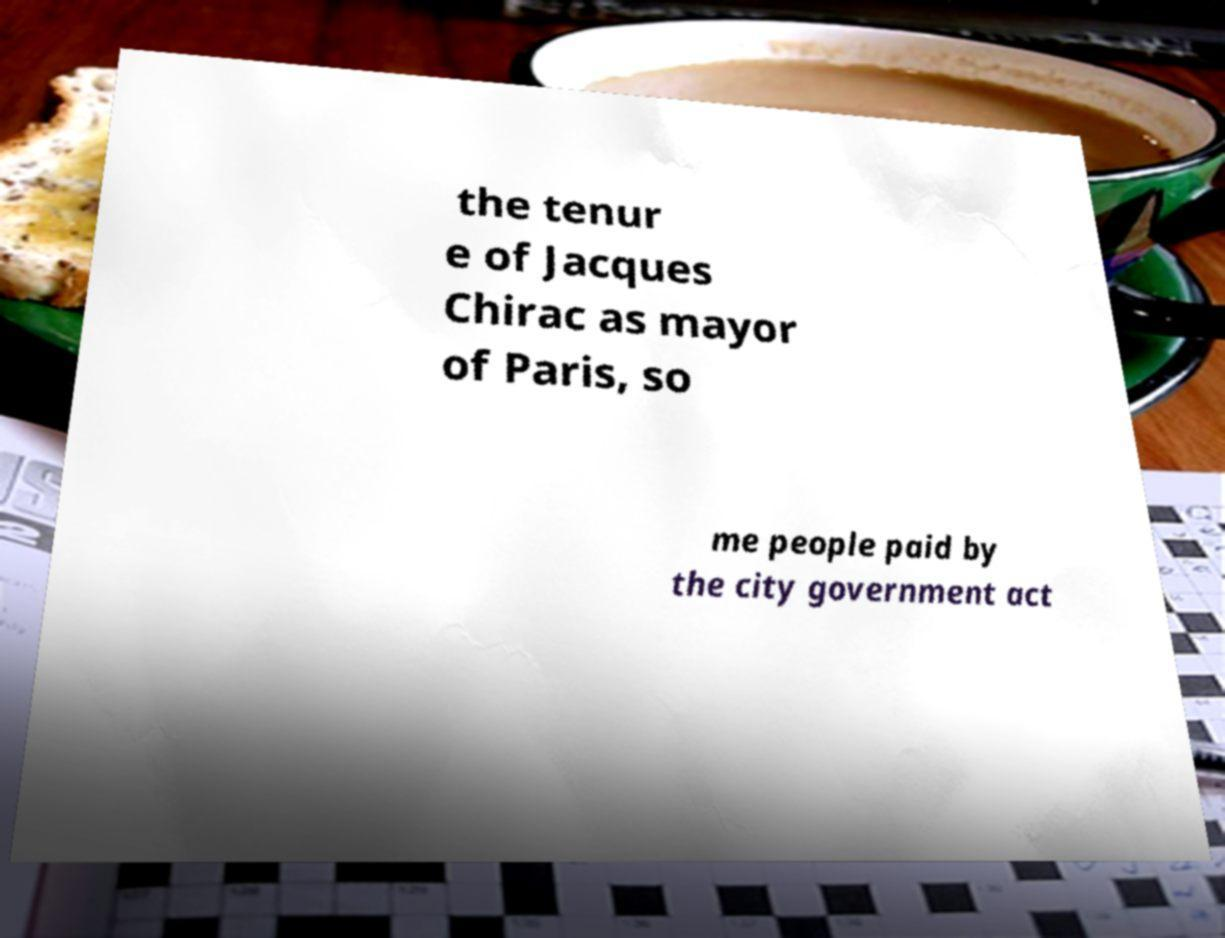I need the written content from this picture converted into text. Can you do that? the tenur e of Jacques Chirac as mayor of Paris, so me people paid by the city government act 